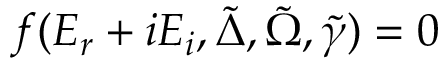Convert formula to latex. <formula><loc_0><loc_0><loc_500><loc_500>f ( E _ { r } + i E _ { i } , \tilde { \Delta } , \tilde { \Omega } , \tilde { \gamma } ) = 0</formula> 